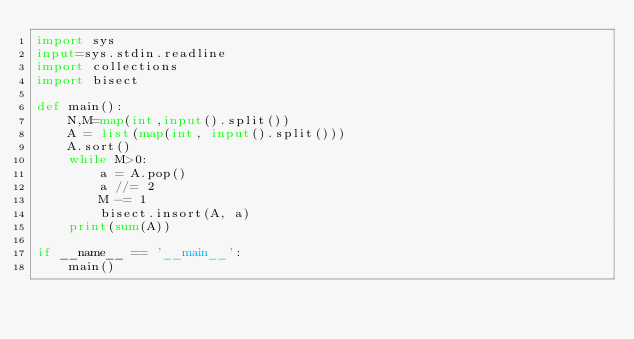<code> <loc_0><loc_0><loc_500><loc_500><_Python_>import sys
input=sys.stdin.readline
import collections
import bisect

def main():
    N,M=map(int,input().split())
    A = list(map(int, input().split()))
    A.sort()
    while M>0:
        a = A.pop()
        a //= 2
        M -= 1
        bisect.insort(A, a)
    print(sum(A))

if __name__ == '__main__':
    main()
</code> 